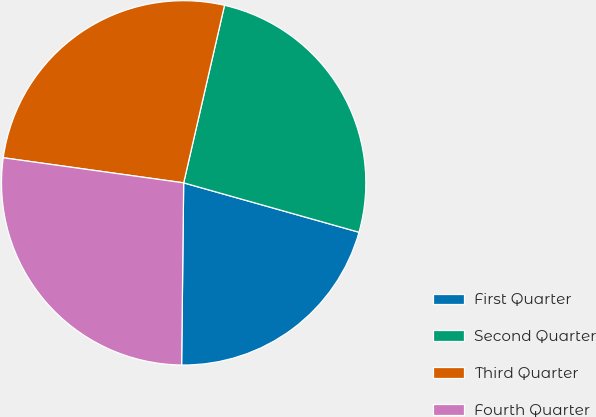<chart> <loc_0><loc_0><loc_500><loc_500><pie_chart><fcel>First Quarter<fcel>Second Quarter<fcel>Third Quarter<fcel>Fourth Quarter<nl><fcel>20.81%<fcel>25.77%<fcel>26.4%<fcel>27.02%<nl></chart> 